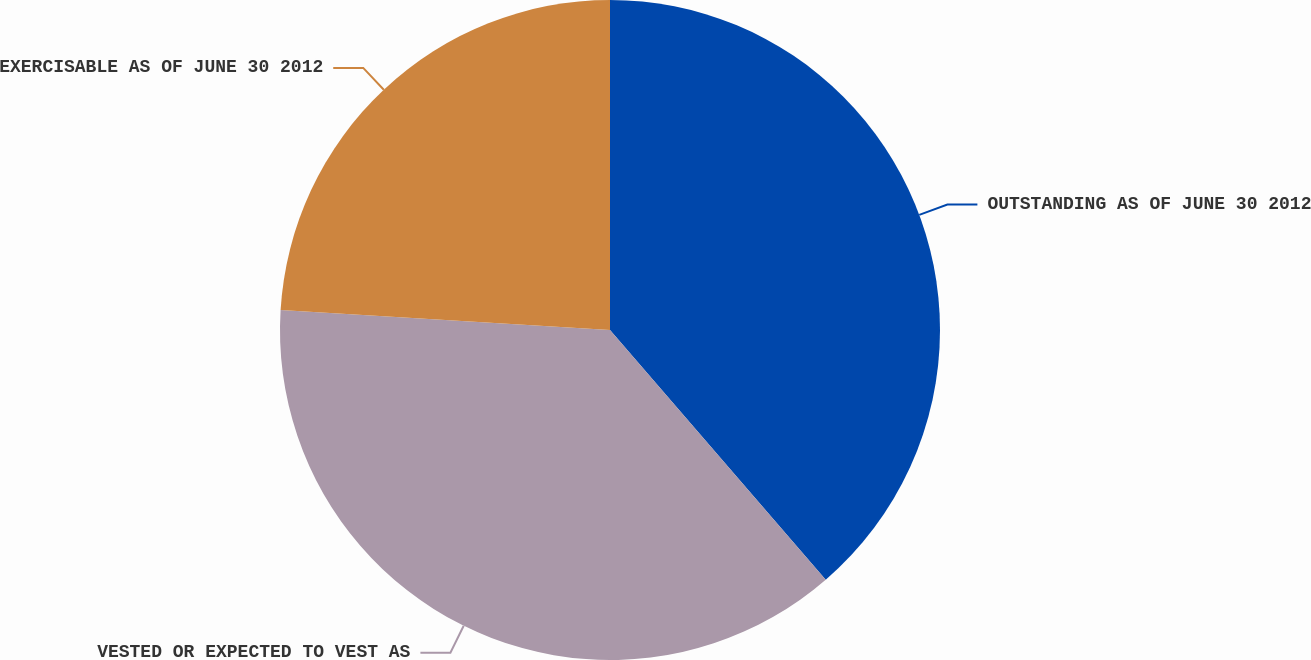Convert chart to OTSL. <chart><loc_0><loc_0><loc_500><loc_500><pie_chart><fcel>OUTSTANDING AS OF JUNE 30 2012<fcel>VESTED OR EXPECTED TO VEST AS<fcel>EXERCISABLE AS OF JUNE 30 2012<nl><fcel>38.66%<fcel>37.3%<fcel>24.04%<nl></chart> 